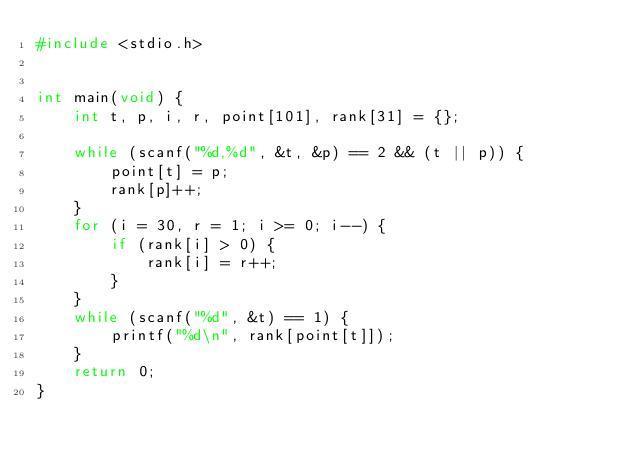<code> <loc_0><loc_0><loc_500><loc_500><_C_>#include <stdio.h>


int main(void) {
    int t, p, i, r, point[101], rank[31] = {};

    while (scanf("%d,%d", &t, &p) == 2 && (t || p)) {
        point[t] = p;
        rank[p]++;
    }
    for (i = 30, r = 1; i >= 0; i--) {
        if (rank[i] > 0) {
            rank[i] = r++;
        }
    }
    while (scanf("%d", &t) == 1) {
        printf("%d\n", rank[point[t]]);
    }
    return 0;
}</code> 